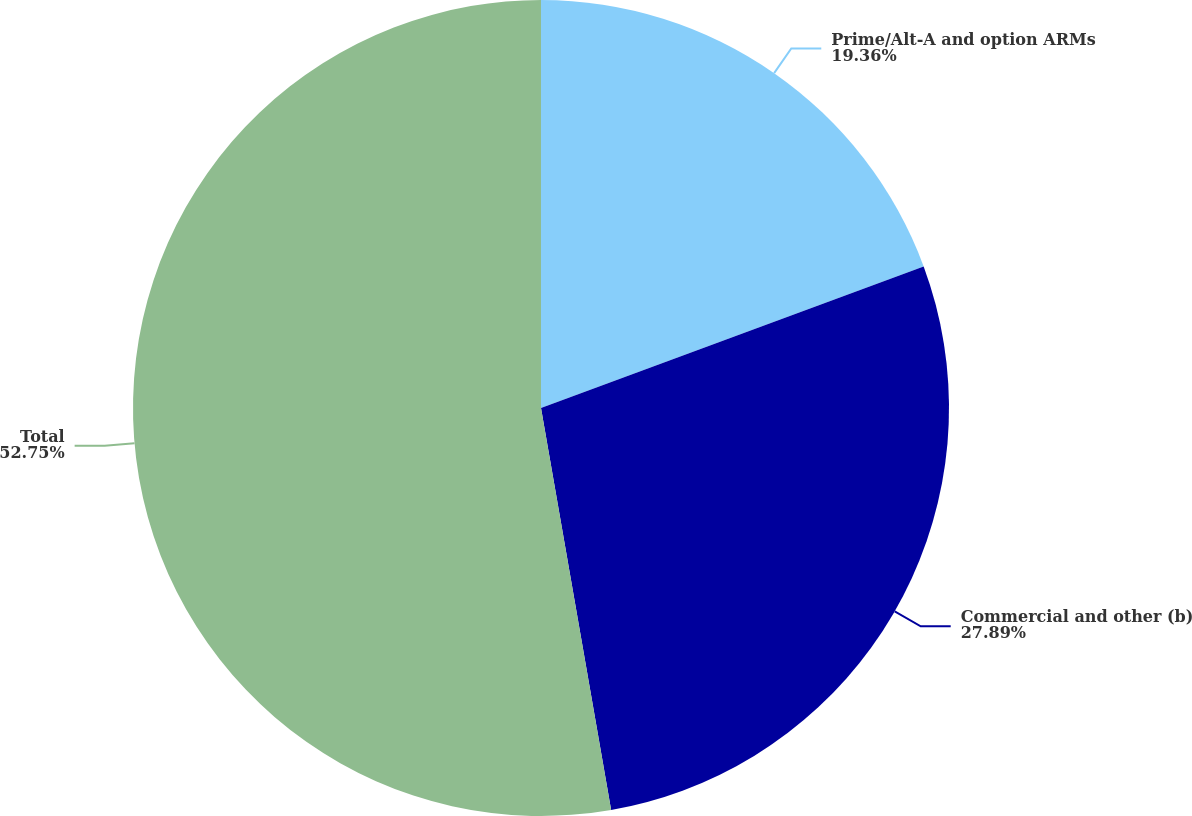<chart> <loc_0><loc_0><loc_500><loc_500><pie_chart><fcel>Prime/Alt-A and option ARMs<fcel>Commercial and other (b)<fcel>Total<nl><fcel>19.36%<fcel>27.89%<fcel>52.75%<nl></chart> 